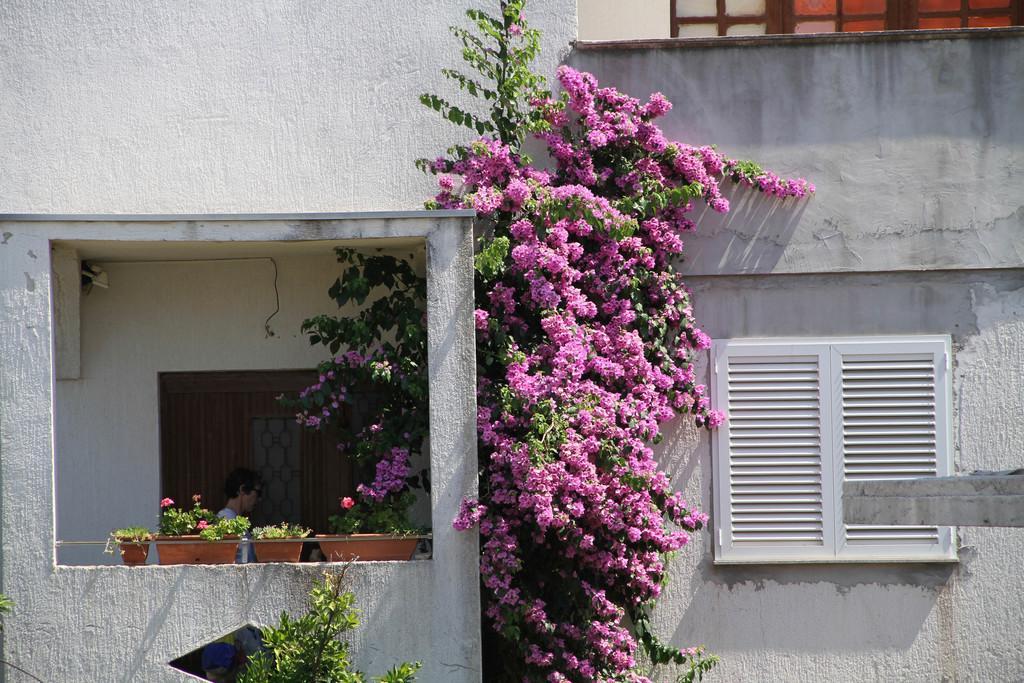In one or two sentences, can you explain what this image depicts? This picture shows a building and we see a human standing and we see trees with flowers and plants in the pots and we see a window. 